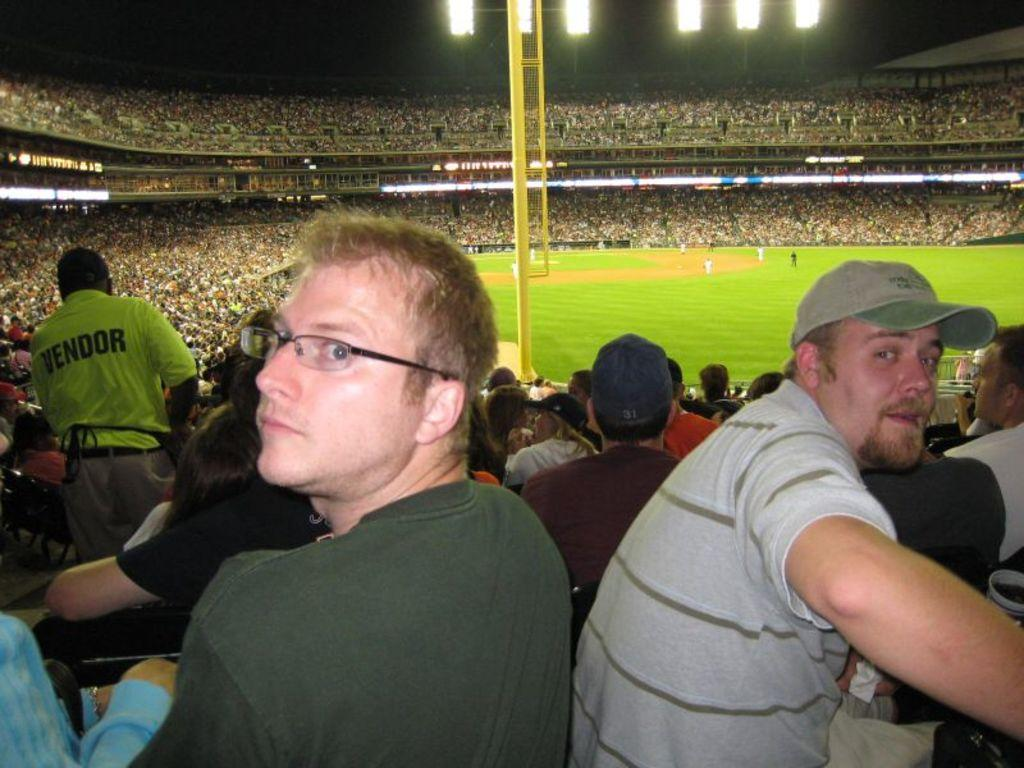What type of venue is depicted in the image? There is a stadium in the image. What are the people in the stadium doing? Some people are sitting and standing, while others are playing in the stadium. Are there any visible features that help illuminate the stadium? Yes, there are lights visible at the top of the stadium. Can you tell me how many basketballs are being kicked by the mom in the image? There is no mom or basketball present in the image. What type of sport is being played by the people in the stadium? The image does not specify the sport being played; it only shows people playing in the stadium. 